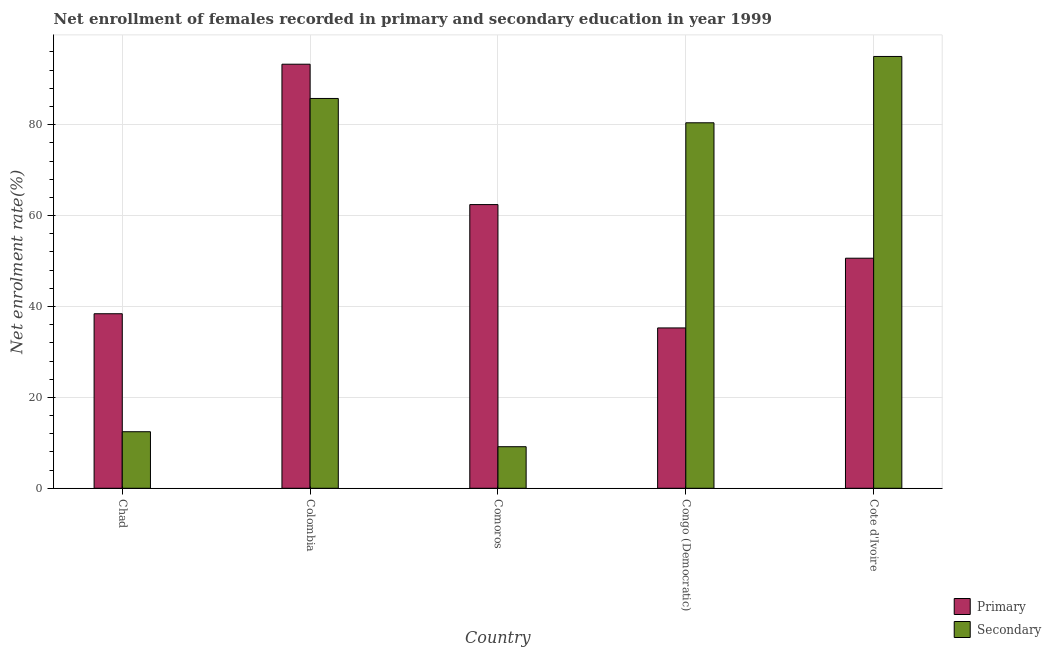How many different coloured bars are there?
Give a very brief answer. 2. How many groups of bars are there?
Your answer should be compact. 5. How many bars are there on the 1st tick from the left?
Offer a terse response. 2. How many bars are there on the 4th tick from the right?
Your answer should be very brief. 2. What is the label of the 3rd group of bars from the left?
Your answer should be compact. Comoros. What is the enrollment rate in secondary education in Chad?
Your response must be concise. 12.44. Across all countries, what is the maximum enrollment rate in secondary education?
Ensure brevity in your answer.  95. Across all countries, what is the minimum enrollment rate in primary education?
Offer a terse response. 35.28. In which country was the enrollment rate in primary education minimum?
Your answer should be compact. Congo (Democratic). What is the total enrollment rate in secondary education in the graph?
Keep it short and to the point. 282.77. What is the difference between the enrollment rate in secondary education in Chad and that in Comoros?
Give a very brief answer. 3.3. What is the difference between the enrollment rate in secondary education in Colombia and the enrollment rate in primary education in Cote d'Ivoire?
Provide a short and direct response. 35.15. What is the average enrollment rate in secondary education per country?
Give a very brief answer. 56.55. What is the difference between the enrollment rate in primary education and enrollment rate in secondary education in Colombia?
Provide a short and direct response. 7.54. What is the ratio of the enrollment rate in secondary education in Colombia to that in Congo (Democratic)?
Ensure brevity in your answer.  1.07. Is the enrollment rate in secondary education in Congo (Democratic) less than that in Cote d'Ivoire?
Your answer should be compact. Yes. What is the difference between the highest and the second highest enrollment rate in secondary education?
Provide a succinct answer. 9.24. What is the difference between the highest and the lowest enrollment rate in primary education?
Provide a short and direct response. 58.02. In how many countries, is the enrollment rate in secondary education greater than the average enrollment rate in secondary education taken over all countries?
Ensure brevity in your answer.  3. What does the 1st bar from the left in Colombia represents?
Make the answer very short. Primary. What does the 2nd bar from the right in Congo (Democratic) represents?
Give a very brief answer. Primary. How many countries are there in the graph?
Your answer should be very brief. 5. What is the difference between two consecutive major ticks on the Y-axis?
Give a very brief answer. 20. Are the values on the major ticks of Y-axis written in scientific E-notation?
Offer a terse response. No. Does the graph contain any zero values?
Offer a very short reply. No. Does the graph contain grids?
Give a very brief answer. Yes. Where does the legend appear in the graph?
Offer a terse response. Bottom right. How many legend labels are there?
Give a very brief answer. 2. How are the legend labels stacked?
Your answer should be very brief. Vertical. What is the title of the graph?
Provide a short and direct response. Net enrollment of females recorded in primary and secondary education in year 1999. Does "Public credit registry" appear as one of the legend labels in the graph?
Make the answer very short. No. What is the label or title of the Y-axis?
Give a very brief answer. Net enrolment rate(%). What is the Net enrolment rate(%) of Primary in Chad?
Your answer should be compact. 38.4. What is the Net enrolment rate(%) of Secondary in Chad?
Provide a short and direct response. 12.44. What is the Net enrolment rate(%) in Primary in Colombia?
Give a very brief answer. 93.3. What is the Net enrolment rate(%) of Secondary in Colombia?
Your answer should be very brief. 85.76. What is the Net enrolment rate(%) in Primary in Comoros?
Your response must be concise. 62.42. What is the Net enrolment rate(%) of Secondary in Comoros?
Ensure brevity in your answer.  9.15. What is the Net enrolment rate(%) of Primary in Congo (Democratic)?
Provide a short and direct response. 35.28. What is the Net enrolment rate(%) of Secondary in Congo (Democratic)?
Give a very brief answer. 80.41. What is the Net enrolment rate(%) in Primary in Cote d'Ivoire?
Your response must be concise. 50.62. What is the Net enrolment rate(%) of Secondary in Cote d'Ivoire?
Provide a short and direct response. 95. Across all countries, what is the maximum Net enrolment rate(%) in Primary?
Make the answer very short. 93.3. Across all countries, what is the maximum Net enrolment rate(%) in Secondary?
Provide a succinct answer. 95. Across all countries, what is the minimum Net enrolment rate(%) of Primary?
Make the answer very short. 35.28. Across all countries, what is the minimum Net enrolment rate(%) of Secondary?
Your response must be concise. 9.15. What is the total Net enrolment rate(%) in Primary in the graph?
Make the answer very short. 280.01. What is the total Net enrolment rate(%) of Secondary in the graph?
Make the answer very short. 282.77. What is the difference between the Net enrolment rate(%) of Primary in Chad and that in Colombia?
Your answer should be compact. -54.9. What is the difference between the Net enrolment rate(%) in Secondary in Chad and that in Colombia?
Ensure brevity in your answer.  -73.32. What is the difference between the Net enrolment rate(%) in Primary in Chad and that in Comoros?
Make the answer very short. -24.01. What is the difference between the Net enrolment rate(%) of Secondary in Chad and that in Comoros?
Your answer should be very brief. 3.3. What is the difference between the Net enrolment rate(%) of Primary in Chad and that in Congo (Democratic)?
Offer a terse response. 3.12. What is the difference between the Net enrolment rate(%) in Secondary in Chad and that in Congo (Democratic)?
Offer a terse response. -67.97. What is the difference between the Net enrolment rate(%) of Primary in Chad and that in Cote d'Ivoire?
Provide a succinct answer. -12.22. What is the difference between the Net enrolment rate(%) of Secondary in Chad and that in Cote d'Ivoire?
Ensure brevity in your answer.  -82.56. What is the difference between the Net enrolment rate(%) of Primary in Colombia and that in Comoros?
Your response must be concise. 30.88. What is the difference between the Net enrolment rate(%) of Secondary in Colombia and that in Comoros?
Provide a succinct answer. 76.62. What is the difference between the Net enrolment rate(%) of Primary in Colombia and that in Congo (Democratic)?
Ensure brevity in your answer.  58.02. What is the difference between the Net enrolment rate(%) in Secondary in Colombia and that in Congo (Democratic)?
Ensure brevity in your answer.  5.35. What is the difference between the Net enrolment rate(%) in Primary in Colombia and that in Cote d'Ivoire?
Give a very brief answer. 42.68. What is the difference between the Net enrolment rate(%) in Secondary in Colombia and that in Cote d'Ivoire?
Keep it short and to the point. -9.24. What is the difference between the Net enrolment rate(%) in Primary in Comoros and that in Congo (Democratic)?
Give a very brief answer. 27.14. What is the difference between the Net enrolment rate(%) in Secondary in Comoros and that in Congo (Democratic)?
Your response must be concise. -71.27. What is the difference between the Net enrolment rate(%) of Primary in Comoros and that in Cote d'Ivoire?
Make the answer very short. 11.8. What is the difference between the Net enrolment rate(%) of Secondary in Comoros and that in Cote d'Ivoire?
Offer a terse response. -85.86. What is the difference between the Net enrolment rate(%) in Primary in Congo (Democratic) and that in Cote d'Ivoire?
Offer a very short reply. -15.34. What is the difference between the Net enrolment rate(%) in Secondary in Congo (Democratic) and that in Cote d'Ivoire?
Keep it short and to the point. -14.59. What is the difference between the Net enrolment rate(%) in Primary in Chad and the Net enrolment rate(%) in Secondary in Colombia?
Ensure brevity in your answer.  -47.36. What is the difference between the Net enrolment rate(%) of Primary in Chad and the Net enrolment rate(%) of Secondary in Comoros?
Your answer should be very brief. 29.25. What is the difference between the Net enrolment rate(%) in Primary in Chad and the Net enrolment rate(%) in Secondary in Congo (Democratic)?
Your response must be concise. -42.01. What is the difference between the Net enrolment rate(%) in Primary in Chad and the Net enrolment rate(%) in Secondary in Cote d'Ivoire?
Provide a short and direct response. -56.6. What is the difference between the Net enrolment rate(%) in Primary in Colombia and the Net enrolment rate(%) in Secondary in Comoros?
Give a very brief answer. 84.15. What is the difference between the Net enrolment rate(%) of Primary in Colombia and the Net enrolment rate(%) of Secondary in Congo (Democratic)?
Give a very brief answer. 12.89. What is the difference between the Net enrolment rate(%) in Primary in Colombia and the Net enrolment rate(%) in Secondary in Cote d'Ivoire?
Your response must be concise. -1.7. What is the difference between the Net enrolment rate(%) in Primary in Comoros and the Net enrolment rate(%) in Secondary in Congo (Democratic)?
Provide a succinct answer. -18. What is the difference between the Net enrolment rate(%) in Primary in Comoros and the Net enrolment rate(%) in Secondary in Cote d'Ivoire?
Provide a succinct answer. -32.59. What is the difference between the Net enrolment rate(%) in Primary in Congo (Democratic) and the Net enrolment rate(%) in Secondary in Cote d'Ivoire?
Your answer should be very brief. -59.72. What is the average Net enrolment rate(%) in Primary per country?
Make the answer very short. 56. What is the average Net enrolment rate(%) in Secondary per country?
Make the answer very short. 56.55. What is the difference between the Net enrolment rate(%) of Primary and Net enrolment rate(%) of Secondary in Chad?
Give a very brief answer. 25.96. What is the difference between the Net enrolment rate(%) of Primary and Net enrolment rate(%) of Secondary in Colombia?
Offer a terse response. 7.54. What is the difference between the Net enrolment rate(%) of Primary and Net enrolment rate(%) of Secondary in Comoros?
Provide a succinct answer. 53.27. What is the difference between the Net enrolment rate(%) of Primary and Net enrolment rate(%) of Secondary in Congo (Democratic)?
Offer a terse response. -45.13. What is the difference between the Net enrolment rate(%) of Primary and Net enrolment rate(%) of Secondary in Cote d'Ivoire?
Keep it short and to the point. -44.39. What is the ratio of the Net enrolment rate(%) of Primary in Chad to that in Colombia?
Offer a terse response. 0.41. What is the ratio of the Net enrolment rate(%) in Secondary in Chad to that in Colombia?
Ensure brevity in your answer.  0.15. What is the ratio of the Net enrolment rate(%) in Primary in Chad to that in Comoros?
Ensure brevity in your answer.  0.62. What is the ratio of the Net enrolment rate(%) in Secondary in Chad to that in Comoros?
Make the answer very short. 1.36. What is the ratio of the Net enrolment rate(%) of Primary in Chad to that in Congo (Democratic)?
Give a very brief answer. 1.09. What is the ratio of the Net enrolment rate(%) of Secondary in Chad to that in Congo (Democratic)?
Offer a terse response. 0.15. What is the ratio of the Net enrolment rate(%) in Primary in Chad to that in Cote d'Ivoire?
Your response must be concise. 0.76. What is the ratio of the Net enrolment rate(%) in Secondary in Chad to that in Cote d'Ivoire?
Provide a succinct answer. 0.13. What is the ratio of the Net enrolment rate(%) in Primary in Colombia to that in Comoros?
Provide a short and direct response. 1.49. What is the ratio of the Net enrolment rate(%) of Secondary in Colombia to that in Comoros?
Make the answer very short. 9.38. What is the ratio of the Net enrolment rate(%) of Primary in Colombia to that in Congo (Democratic)?
Provide a short and direct response. 2.64. What is the ratio of the Net enrolment rate(%) of Secondary in Colombia to that in Congo (Democratic)?
Keep it short and to the point. 1.07. What is the ratio of the Net enrolment rate(%) in Primary in Colombia to that in Cote d'Ivoire?
Your response must be concise. 1.84. What is the ratio of the Net enrolment rate(%) in Secondary in Colombia to that in Cote d'Ivoire?
Give a very brief answer. 0.9. What is the ratio of the Net enrolment rate(%) in Primary in Comoros to that in Congo (Democratic)?
Give a very brief answer. 1.77. What is the ratio of the Net enrolment rate(%) in Secondary in Comoros to that in Congo (Democratic)?
Your answer should be compact. 0.11. What is the ratio of the Net enrolment rate(%) of Primary in Comoros to that in Cote d'Ivoire?
Offer a very short reply. 1.23. What is the ratio of the Net enrolment rate(%) of Secondary in Comoros to that in Cote d'Ivoire?
Give a very brief answer. 0.1. What is the ratio of the Net enrolment rate(%) in Primary in Congo (Democratic) to that in Cote d'Ivoire?
Give a very brief answer. 0.7. What is the ratio of the Net enrolment rate(%) of Secondary in Congo (Democratic) to that in Cote d'Ivoire?
Your answer should be very brief. 0.85. What is the difference between the highest and the second highest Net enrolment rate(%) in Primary?
Make the answer very short. 30.88. What is the difference between the highest and the second highest Net enrolment rate(%) in Secondary?
Make the answer very short. 9.24. What is the difference between the highest and the lowest Net enrolment rate(%) in Primary?
Give a very brief answer. 58.02. What is the difference between the highest and the lowest Net enrolment rate(%) of Secondary?
Make the answer very short. 85.86. 